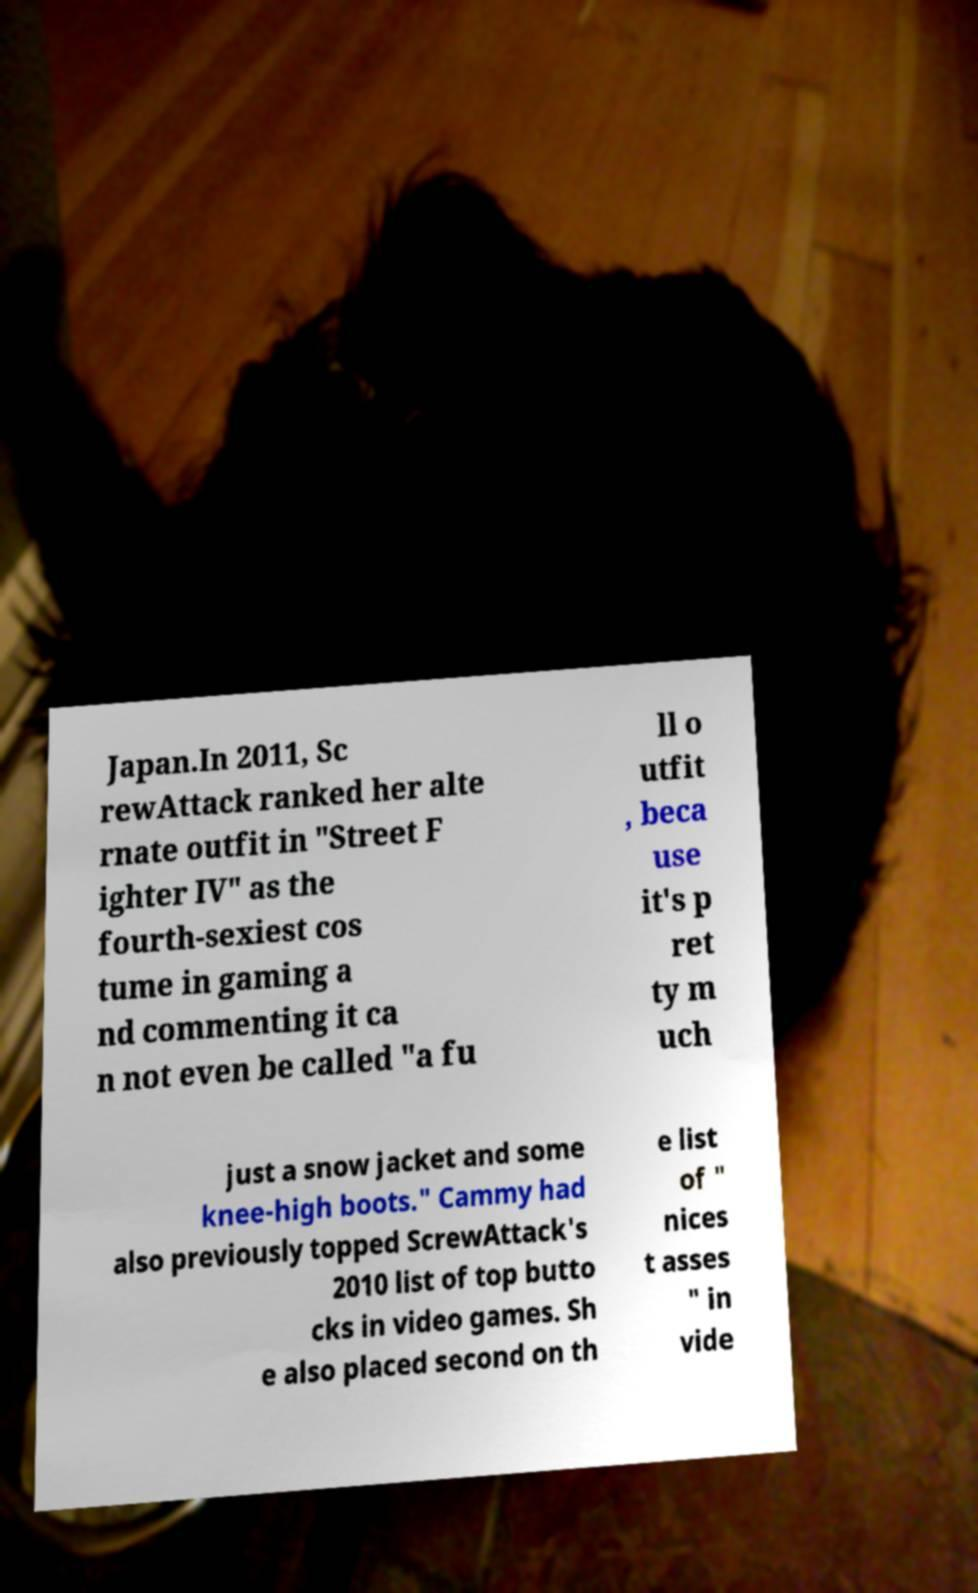Could you extract and type out the text from this image? Japan.In 2011, Sc rewAttack ranked her alte rnate outfit in "Street F ighter IV" as the fourth-sexiest cos tume in gaming a nd commenting it ca n not even be called "a fu ll o utfit , beca use it's p ret ty m uch just a snow jacket and some knee-high boots." Cammy had also previously topped ScrewAttack's 2010 list of top butto cks in video games. Sh e also placed second on th e list of " nices t asses " in vide 